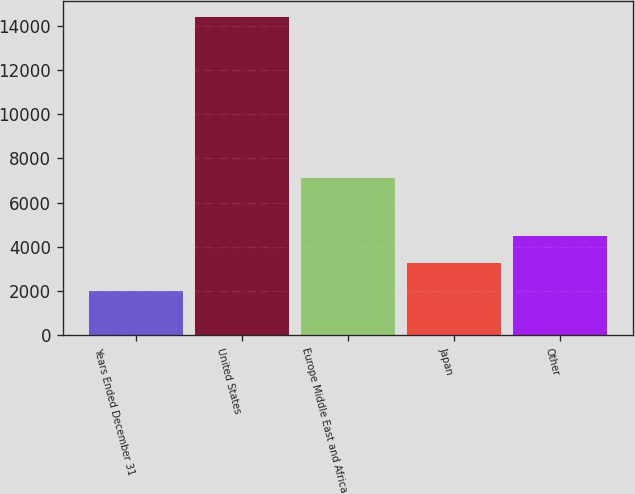Convert chart. <chart><loc_0><loc_0><loc_500><loc_500><bar_chart><fcel>Years Ended December 31<fcel>United States<fcel>Europe Middle East and Africa<fcel>Japan<fcel>Other<nl><fcel>2009<fcel>14401.2<fcel>7093.1<fcel>3248.22<fcel>4487.44<nl></chart> 